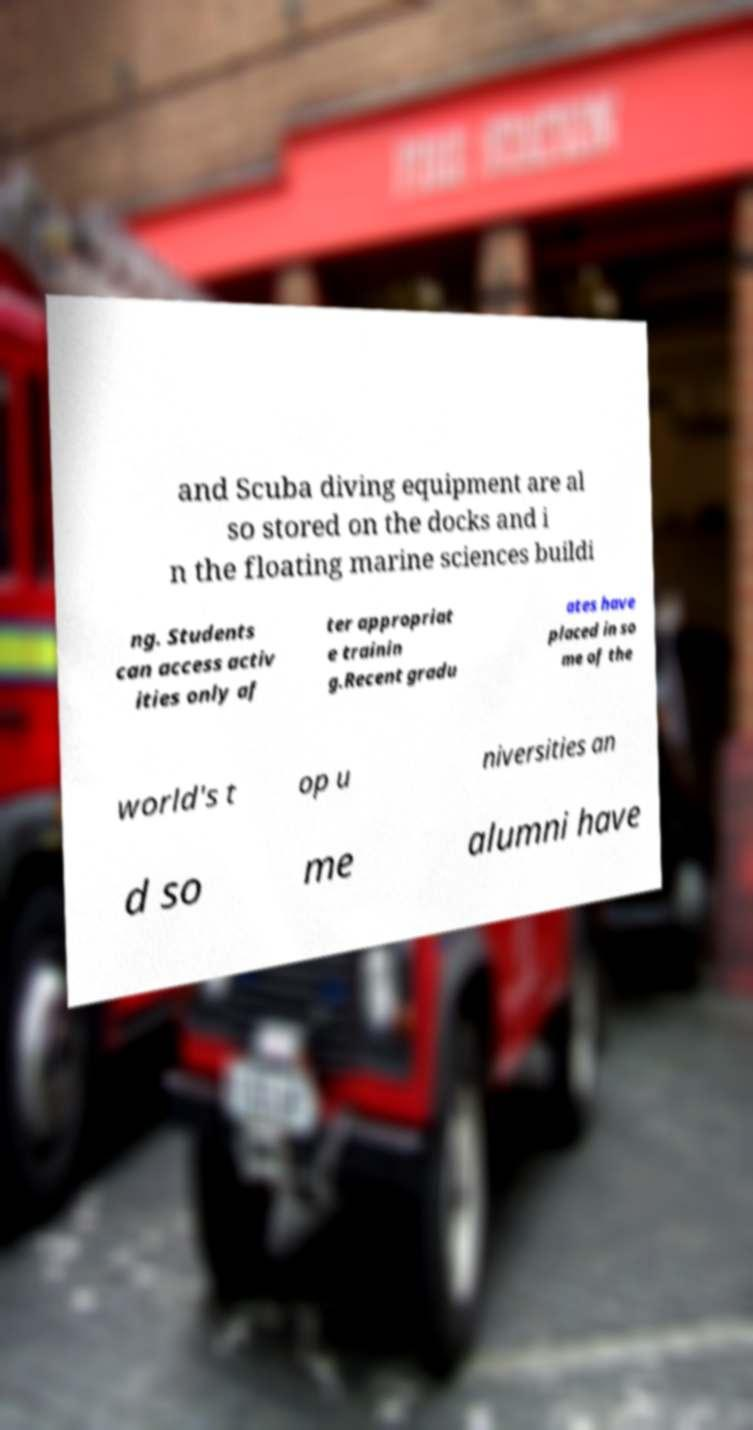For documentation purposes, I need the text within this image transcribed. Could you provide that? and Scuba diving equipment are al so stored on the docks and i n the floating marine sciences buildi ng. Students can access activ ities only af ter appropriat e trainin g.Recent gradu ates have placed in so me of the world's t op u niversities an d so me alumni have 